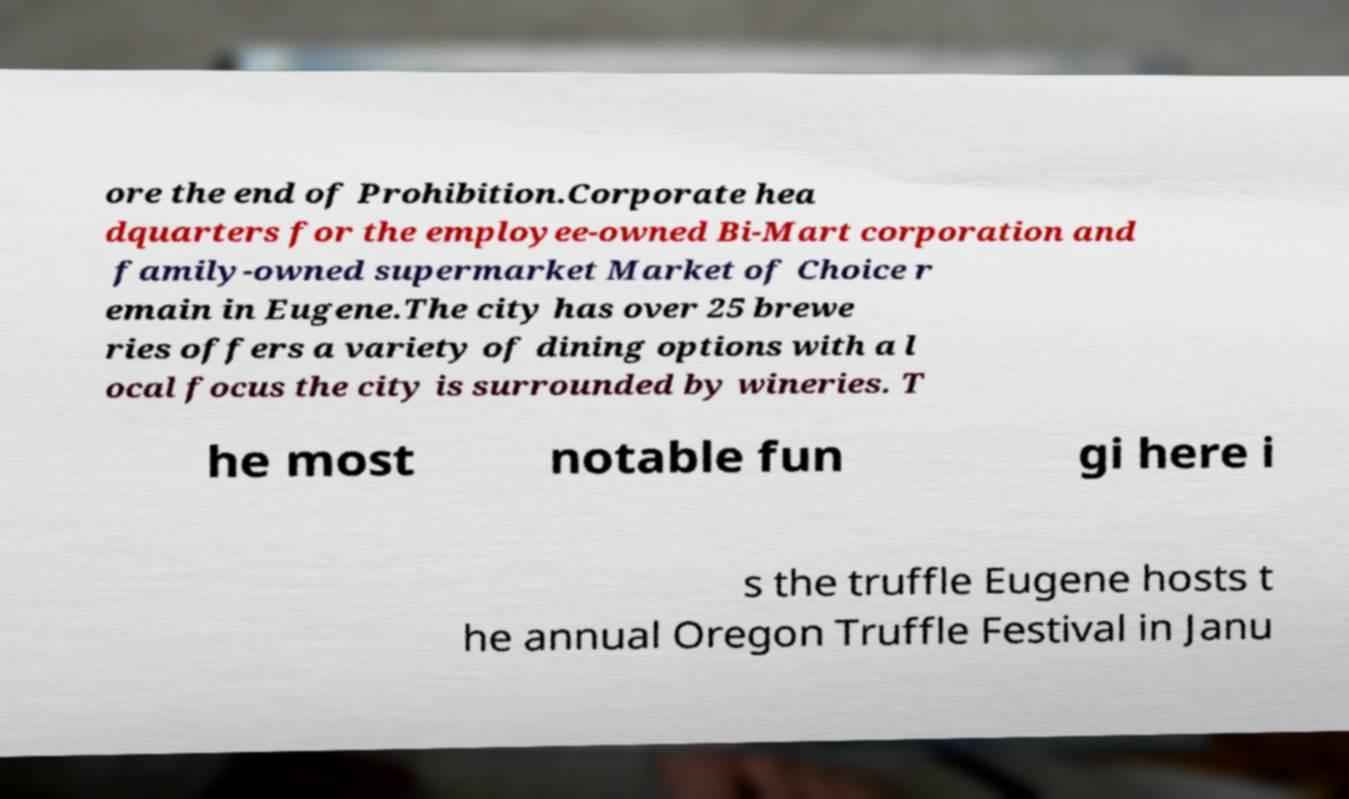Could you assist in decoding the text presented in this image and type it out clearly? ore the end of Prohibition.Corporate hea dquarters for the employee-owned Bi-Mart corporation and family-owned supermarket Market of Choice r emain in Eugene.The city has over 25 brewe ries offers a variety of dining options with a l ocal focus the city is surrounded by wineries. T he most notable fun gi here i s the truffle Eugene hosts t he annual Oregon Truffle Festival in Janu 